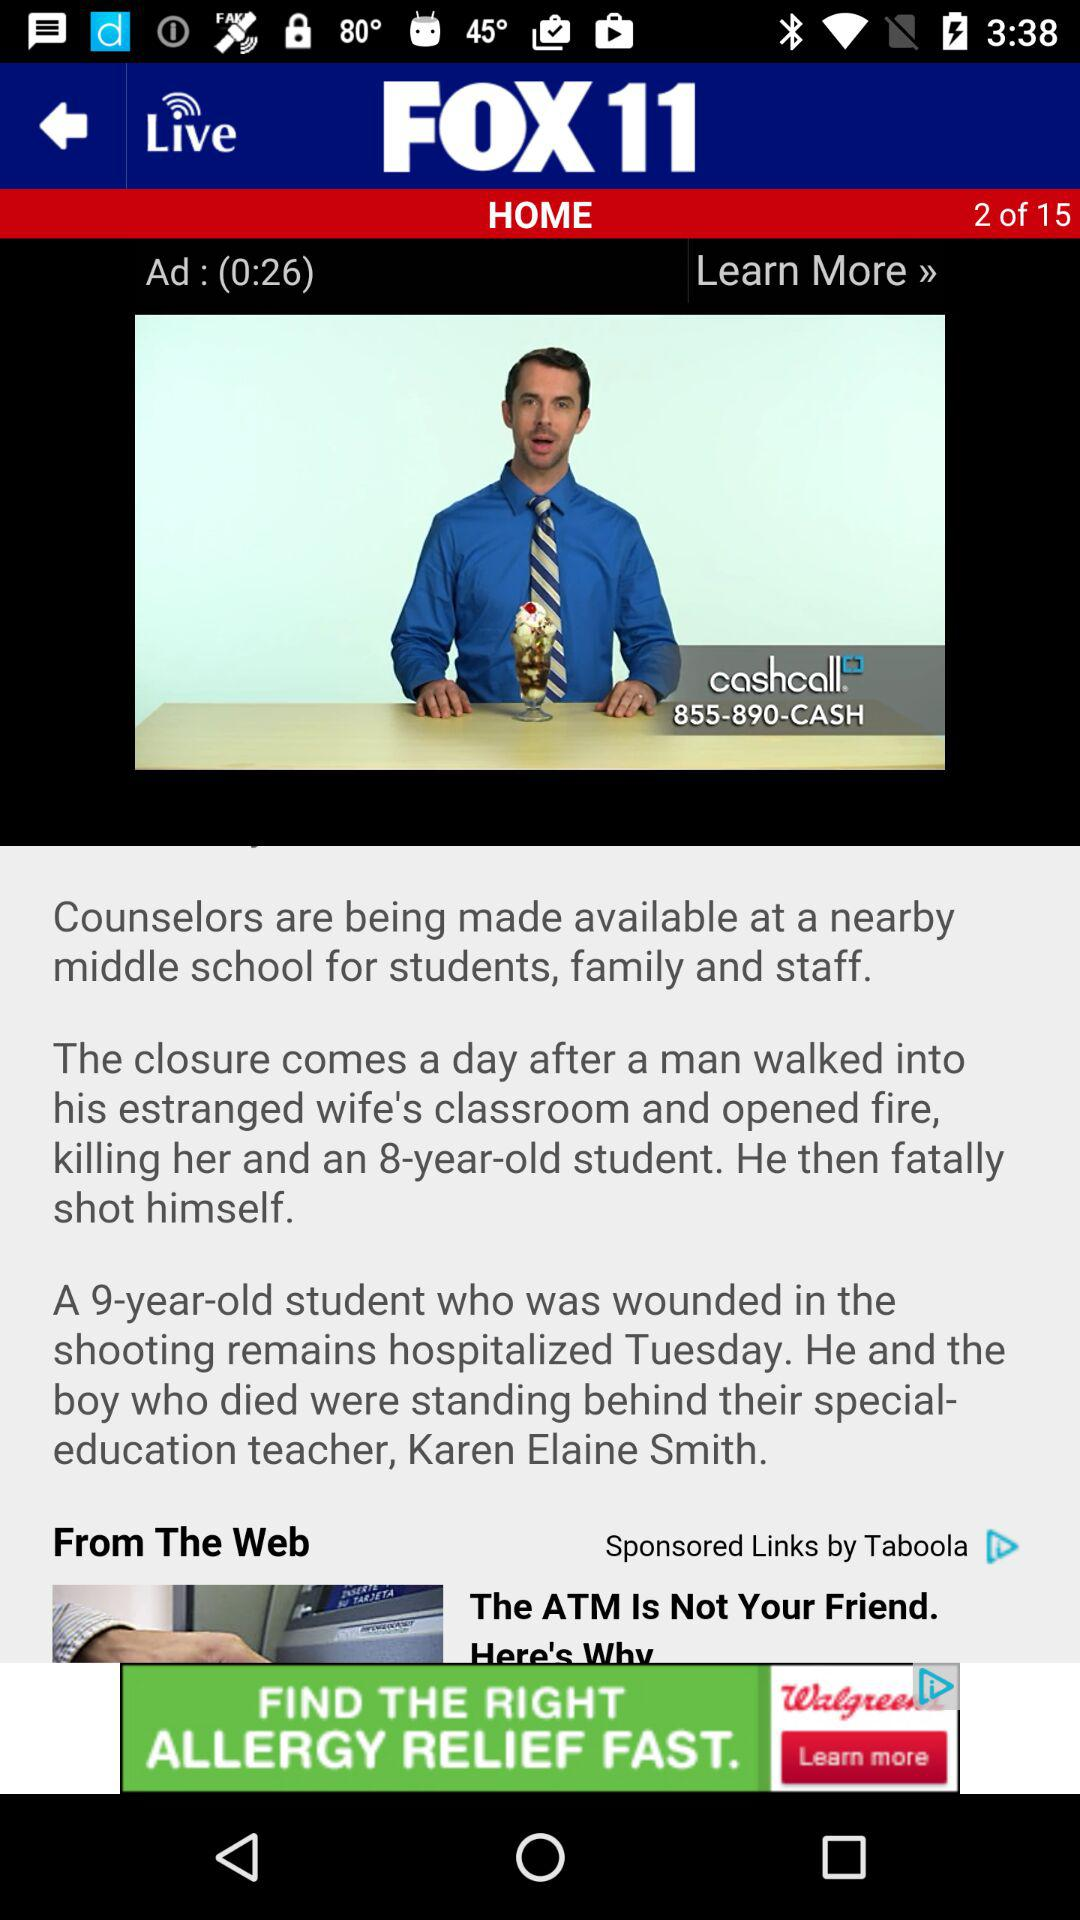How many pages in total are there? There are 15 pages. 